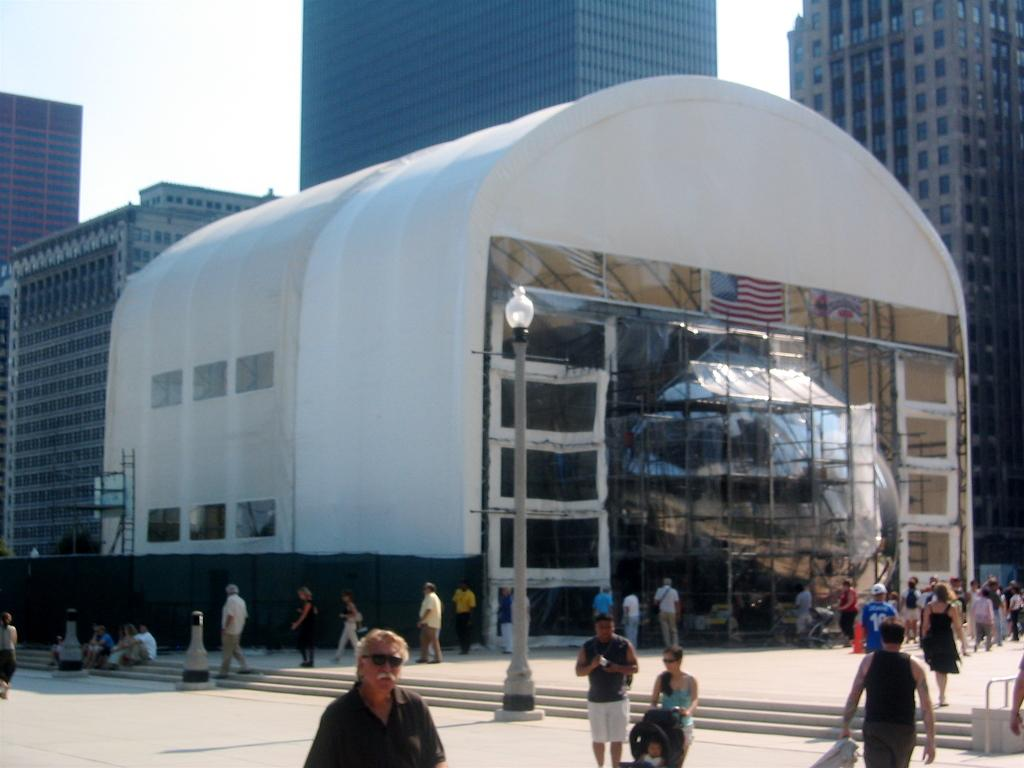What type of structures are visible in the image? There is a group of buildings in the image. What is happening in front of the buildings? There is a group of persons in front of the buildings. What architectural feature is present in front of the buildings? There are stairs in front of the buildings. What is attached to the pole in front of the buildings? There is a light attached to the pole in front of the buildings. What is visible at the top of the image? The sky is visible at the top of the image. What type of bread is being used to build the stairs in the image? There is no bread present in the image, and the stairs are not made of bread. 